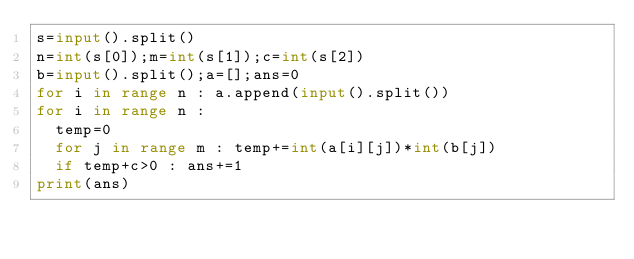<code> <loc_0><loc_0><loc_500><loc_500><_Python_>s=input().split()
n=int(s[0]);m=int(s[1]);c=int(s[2])
b=input().split();a=[];ans=0
for i in range n : a.append(input().split())
for i in range n :
  temp=0
  for j in range m : temp+=int(a[i][j])*int(b[j])
  if temp+c>0 : ans+=1
print(ans)</code> 